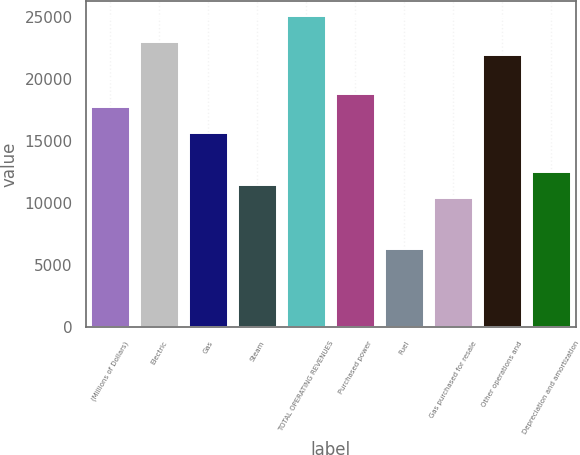Convert chart to OTSL. <chart><loc_0><loc_0><loc_500><loc_500><bar_chart><fcel>(Millions of Dollars)<fcel>Electric<fcel>Gas<fcel>Steam<fcel>TOTAL OPERATING REVENUES<fcel>Purchased power<fcel>Fuel<fcel>Gas purchased for resale<fcel>Other operations and<fcel>Depreciation and amortization<nl><fcel>17730.3<fcel>22944.8<fcel>15644.5<fcel>11472.9<fcel>25030.6<fcel>18773.2<fcel>6258.4<fcel>10430<fcel>21901.9<fcel>12515.8<nl></chart> 